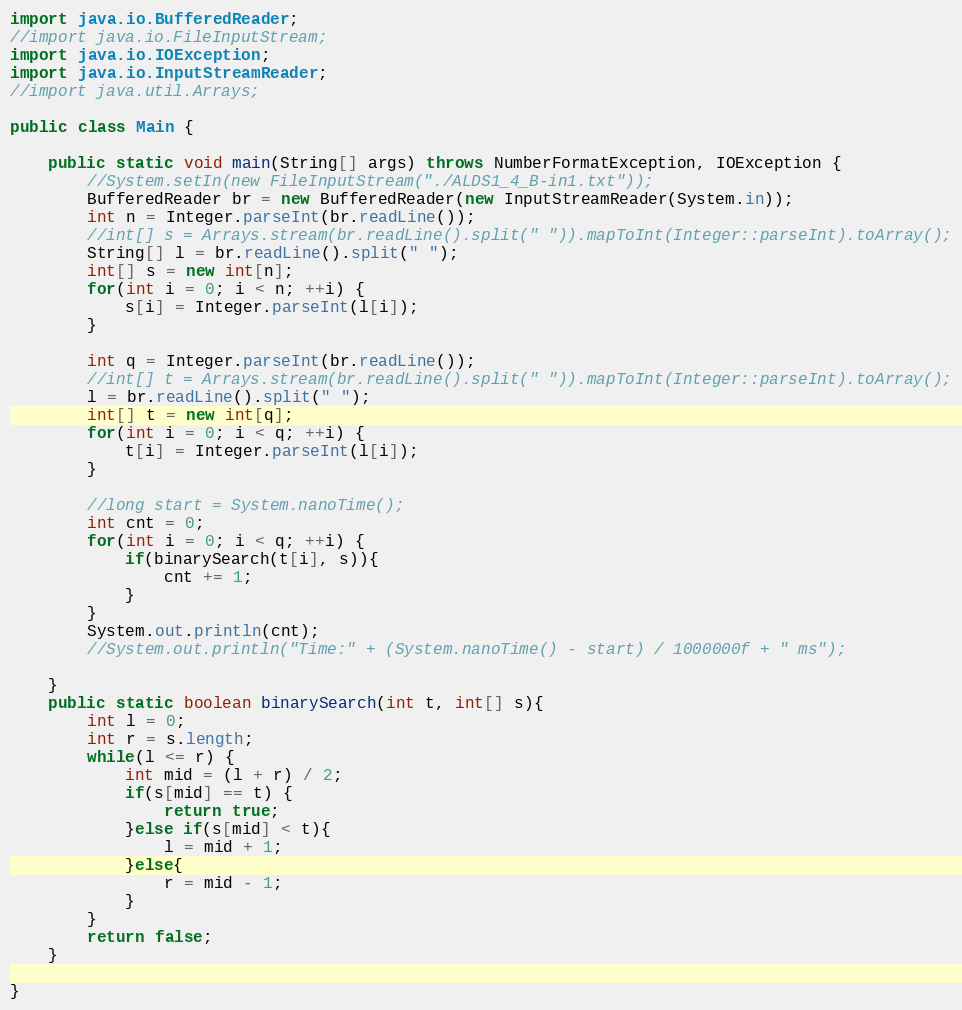<code> <loc_0><loc_0><loc_500><loc_500><_Java_>import java.io.BufferedReader;
//import java.io.FileInputStream;
import java.io.IOException;
import java.io.InputStreamReader;
//import java.util.Arrays;

public class Main {

	public static void main(String[] args) throws NumberFormatException, IOException {
		//System.setIn(new FileInputStream("./ALDS1_4_B-in1.txt"));
		BufferedReader br = new BufferedReader(new InputStreamReader(System.in));
		int n = Integer.parseInt(br.readLine());
		//int[] s = Arrays.stream(br.readLine().split(" ")).mapToInt(Integer::parseInt).toArray();
		String[] l = br.readLine().split(" ");
		int[] s = new int[n];
		for(int i = 0; i < n; ++i) {
			s[i] = Integer.parseInt(l[i]);
		}
		
		int q = Integer.parseInt(br.readLine());
		//int[] t = Arrays.stream(br.readLine().split(" ")).mapToInt(Integer::parseInt).toArray();
		l = br.readLine().split(" ");
		int[] t = new int[q];
		for(int i = 0; i < q; ++i) {
			t[i] = Integer.parseInt(l[i]);
		}
		
		//long start = System.nanoTime();
		int cnt = 0;
		for(int i = 0; i < q; ++i) {
			if(binarySearch(t[i], s)){
				cnt += 1;
			}
		}
		System.out.println(cnt);
		//System.out.println("Time:" + (System.nanoTime() - start) / 1000000f + " ms");

	}
	public static boolean binarySearch(int t, int[] s){
		int l = 0;
		int r = s.length;
		while(l <= r) {
			int mid = (l + r) / 2;
			if(s[mid] == t) {
				return true;
			}else if(s[mid] < t){
				l = mid + 1;
			}else{
				r = mid - 1;
			}
		}
		return false;
	}

}</code> 